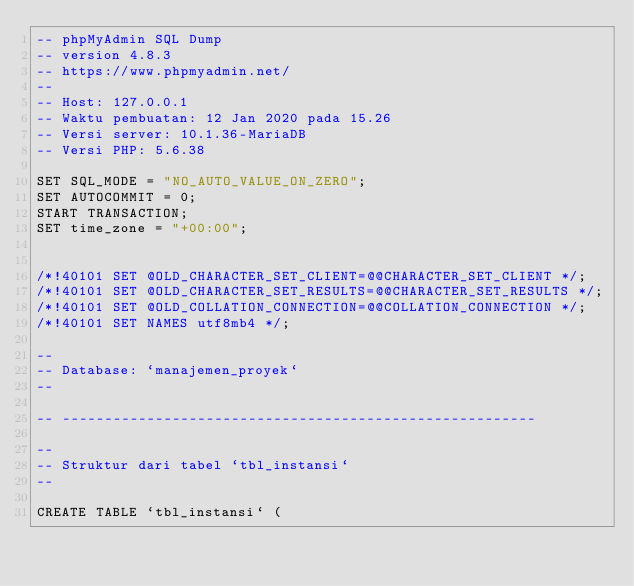<code> <loc_0><loc_0><loc_500><loc_500><_SQL_>-- phpMyAdmin SQL Dump
-- version 4.8.3
-- https://www.phpmyadmin.net/
--
-- Host: 127.0.0.1
-- Waktu pembuatan: 12 Jan 2020 pada 15.26
-- Versi server: 10.1.36-MariaDB
-- Versi PHP: 5.6.38

SET SQL_MODE = "NO_AUTO_VALUE_ON_ZERO";
SET AUTOCOMMIT = 0;
START TRANSACTION;
SET time_zone = "+00:00";


/*!40101 SET @OLD_CHARACTER_SET_CLIENT=@@CHARACTER_SET_CLIENT */;
/*!40101 SET @OLD_CHARACTER_SET_RESULTS=@@CHARACTER_SET_RESULTS */;
/*!40101 SET @OLD_COLLATION_CONNECTION=@@COLLATION_CONNECTION */;
/*!40101 SET NAMES utf8mb4 */;

--
-- Database: `manajemen_proyek`
--

-- --------------------------------------------------------

--
-- Struktur dari tabel `tbl_instansi`
--

CREATE TABLE `tbl_instansi` (</code> 